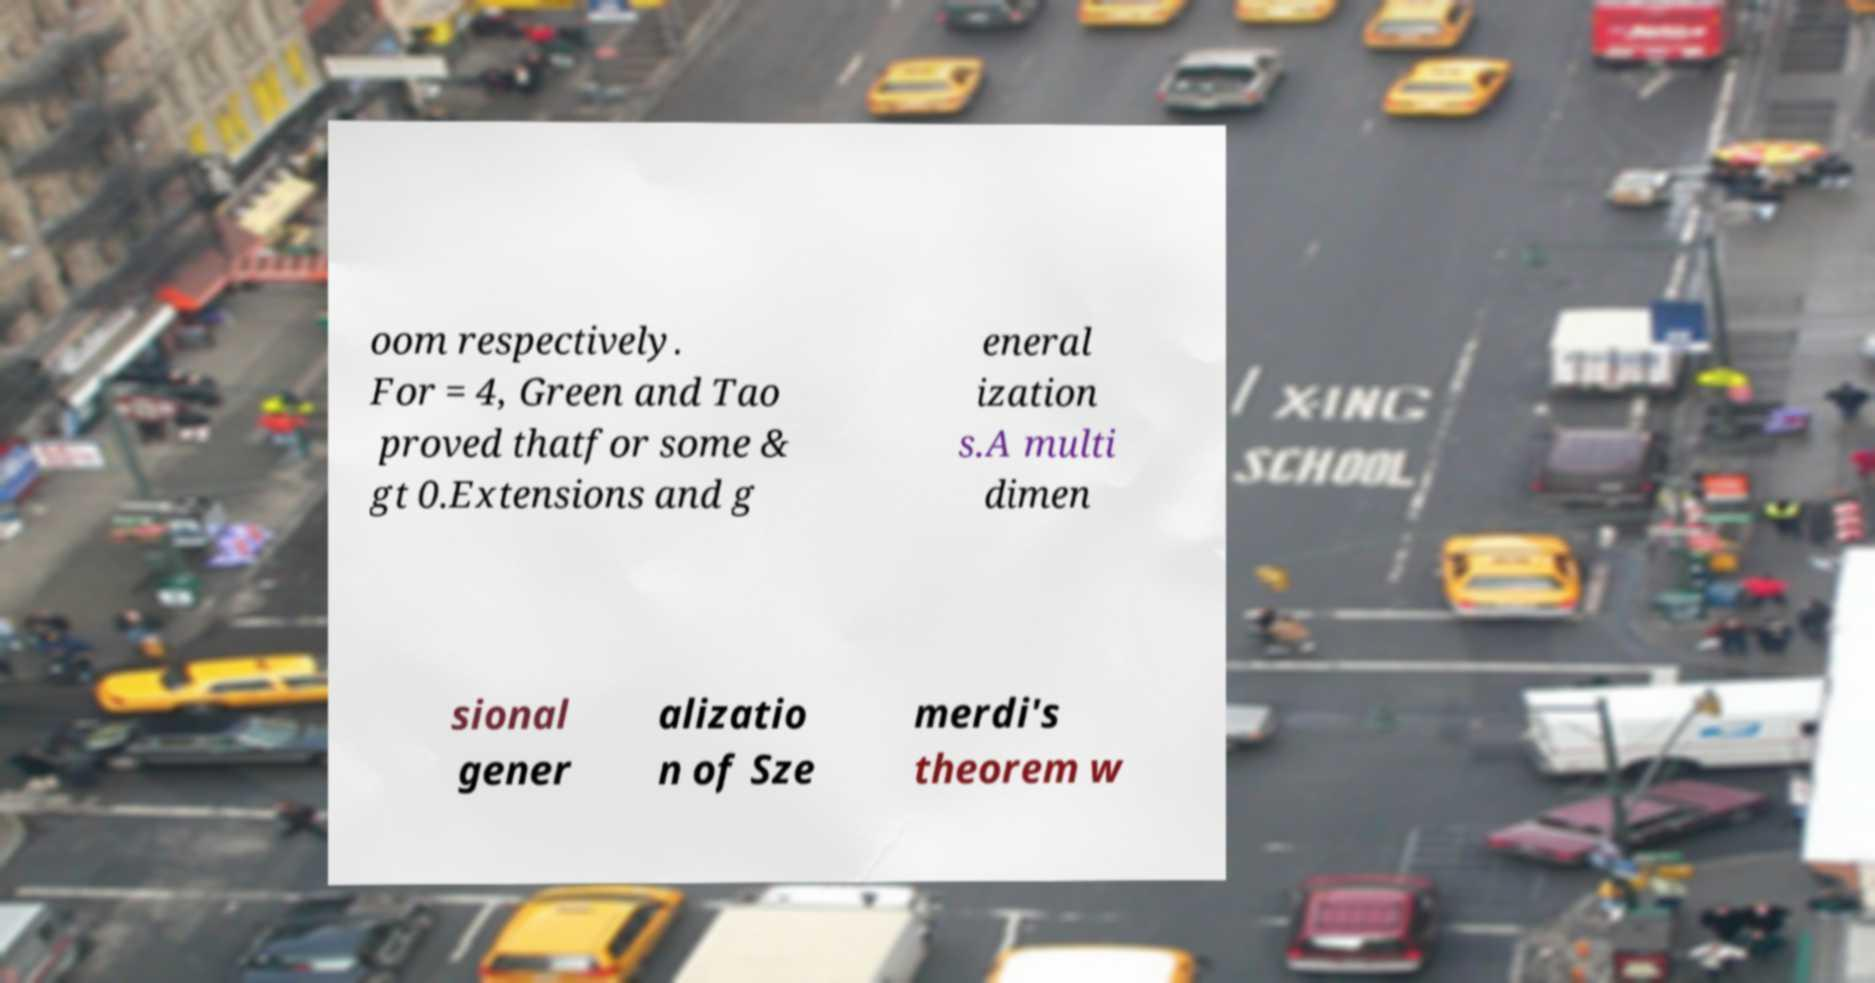Please identify and transcribe the text found in this image. oom respectively. For = 4, Green and Tao proved thatfor some & gt 0.Extensions and g eneral ization s.A multi dimen sional gener alizatio n of Sze merdi's theorem w 